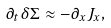<formula> <loc_0><loc_0><loc_500><loc_500>\partial _ { t } \delta \Sigma \approx - \partial _ { x } J _ { x } ,</formula> 